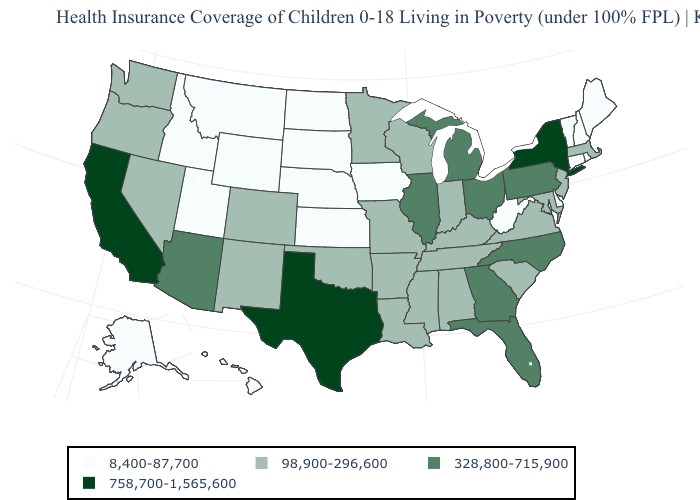How many symbols are there in the legend?
Keep it brief. 4. Among the states that border Connecticut , which have the lowest value?
Give a very brief answer. Rhode Island. Name the states that have a value in the range 758,700-1,565,600?
Keep it brief. California, New York, Texas. Does Nebraska have a higher value than Illinois?
Quick response, please. No. Is the legend a continuous bar?
Be succinct. No. Among the states that border South Carolina , which have the highest value?
Quick response, please. Georgia, North Carolina. What is the value of Oregon?
Short answer required. 98,900-296,600. What is the highest value in states that border Florida?
Keep it brief. 328,800-715,900. Does the map have missing data?
Be succinct. No. Among the states that border Georgia , which have the highest value?
Short answer required. Florida, North Carolina. What is the value of Nevada?
Keep it brief. 98,900-296,600. What is the highest value in the West ?
Keep it brief. 758,700-1,565,600. Is the legend a continuous bar?
Answer briefly. No. Which states have the lowest value in the MidWest?
Keep it brief. Iowa, Kansas, Nebraska, North Dakota, South Dakota. 